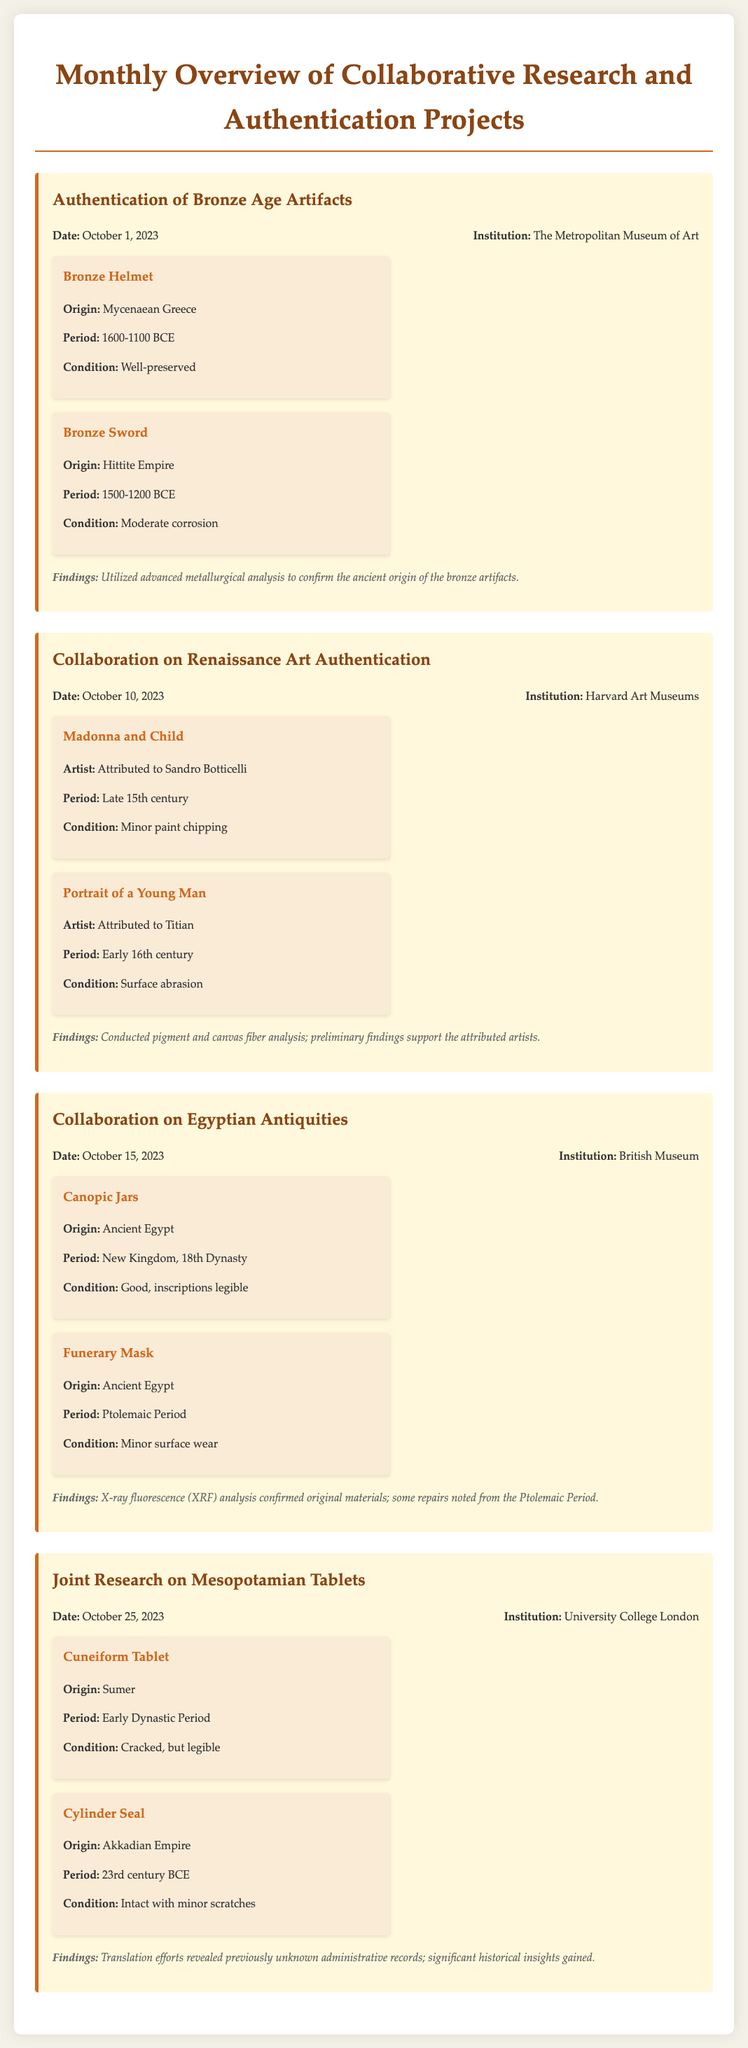What is the title of the document? The title is prominently displayed at the top of the document, indicating the focus on monthly overview and collaborative research projects.
Answer: Monthly Overview of Collaborative Research and Authentication Projects When was the collaboration on Renaissance Art Authentication conducted? The date is specified within the project section, giving a clear timeline for when the research took place.
Answer: October 10, 2023 Which artifact originates from Mycenaean Greece? The information regarding the artifacts includes their origin, allowing for direct identification of specific items.
Answer: Bronze Helmet What analysis method confirmed the ancient origin of the bronze artifacts? The findings section mentions the method used in the authentication, requiring an understanding of the specific techniques.
Answer: Advanced metallurgical analysis Who partnered with the British Museum for the Egyptian Antiquities project? The document lists institutions involved in each project, providing insight into collaborative efforts in art authentication.
Answer: British Museum Which project involved the study of cuneiform tablets? The project title clearly indicates the subject matter explored in the collaborative research, signaling those specific artifacts involved.
Answer: Joint Research on Mesopotamian Tablets What is the period of the Funerary Mask? Each artifact includes detailed information about the period, facilitating clear extraction of historical context for items studied.
Answer: Ptolemaic Period How many artifacts were studied in the project on Bronze Age Artifacts? The project details provide a count of artifacts associated with each specific project on the overview.
Answer: 2 